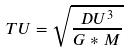Convert formula to latex. <formula><loc_0><loc_0><loc_500><loc_500>T U = \sqrt { \frac { D U ^ { 3 } } { G * M } }</formula> 